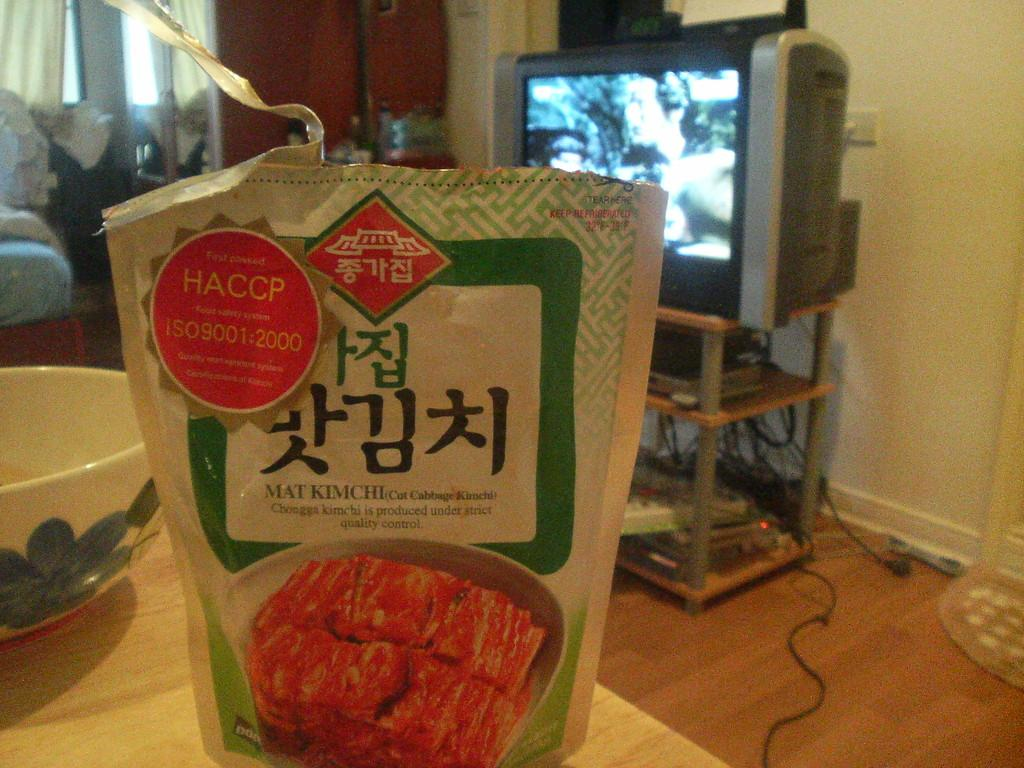<image>
Create a compact narrative representing the image presented. A foreign brand of food that says HACCP on it. 